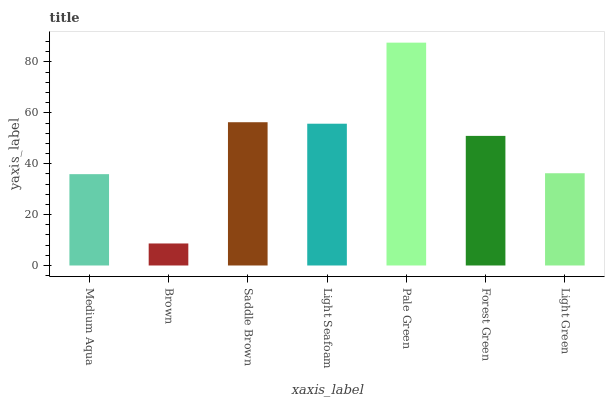Is Brown the minimum?
Answer yes or no. Yes. Is Pale Green the maximum?
Answer yes or no. Yes. Is Saddle Brown the minimum?
Answer yes or no. No. Is Saddle Brown the maximum?
Answer yes or no. No. Is Saddle Brown greater than Brown?
Answer yes or no. Yes. Is Brown less than Saddle Brown?
Answer yes or no. Yes. Is Brown greater than Saddle Brown?
Answer yes or no. No. Is Saddle Brown less than Brown?
Answer yes or no. No. Is Forest Green the high median?
Answer yes or no. Yes. Is Forest Green the low median?
Answer yes or no. Yes. Is Light Green the high median?
Answer yes or no. No. Is Saddle Brown the low median?
Answer yes or no. No. 